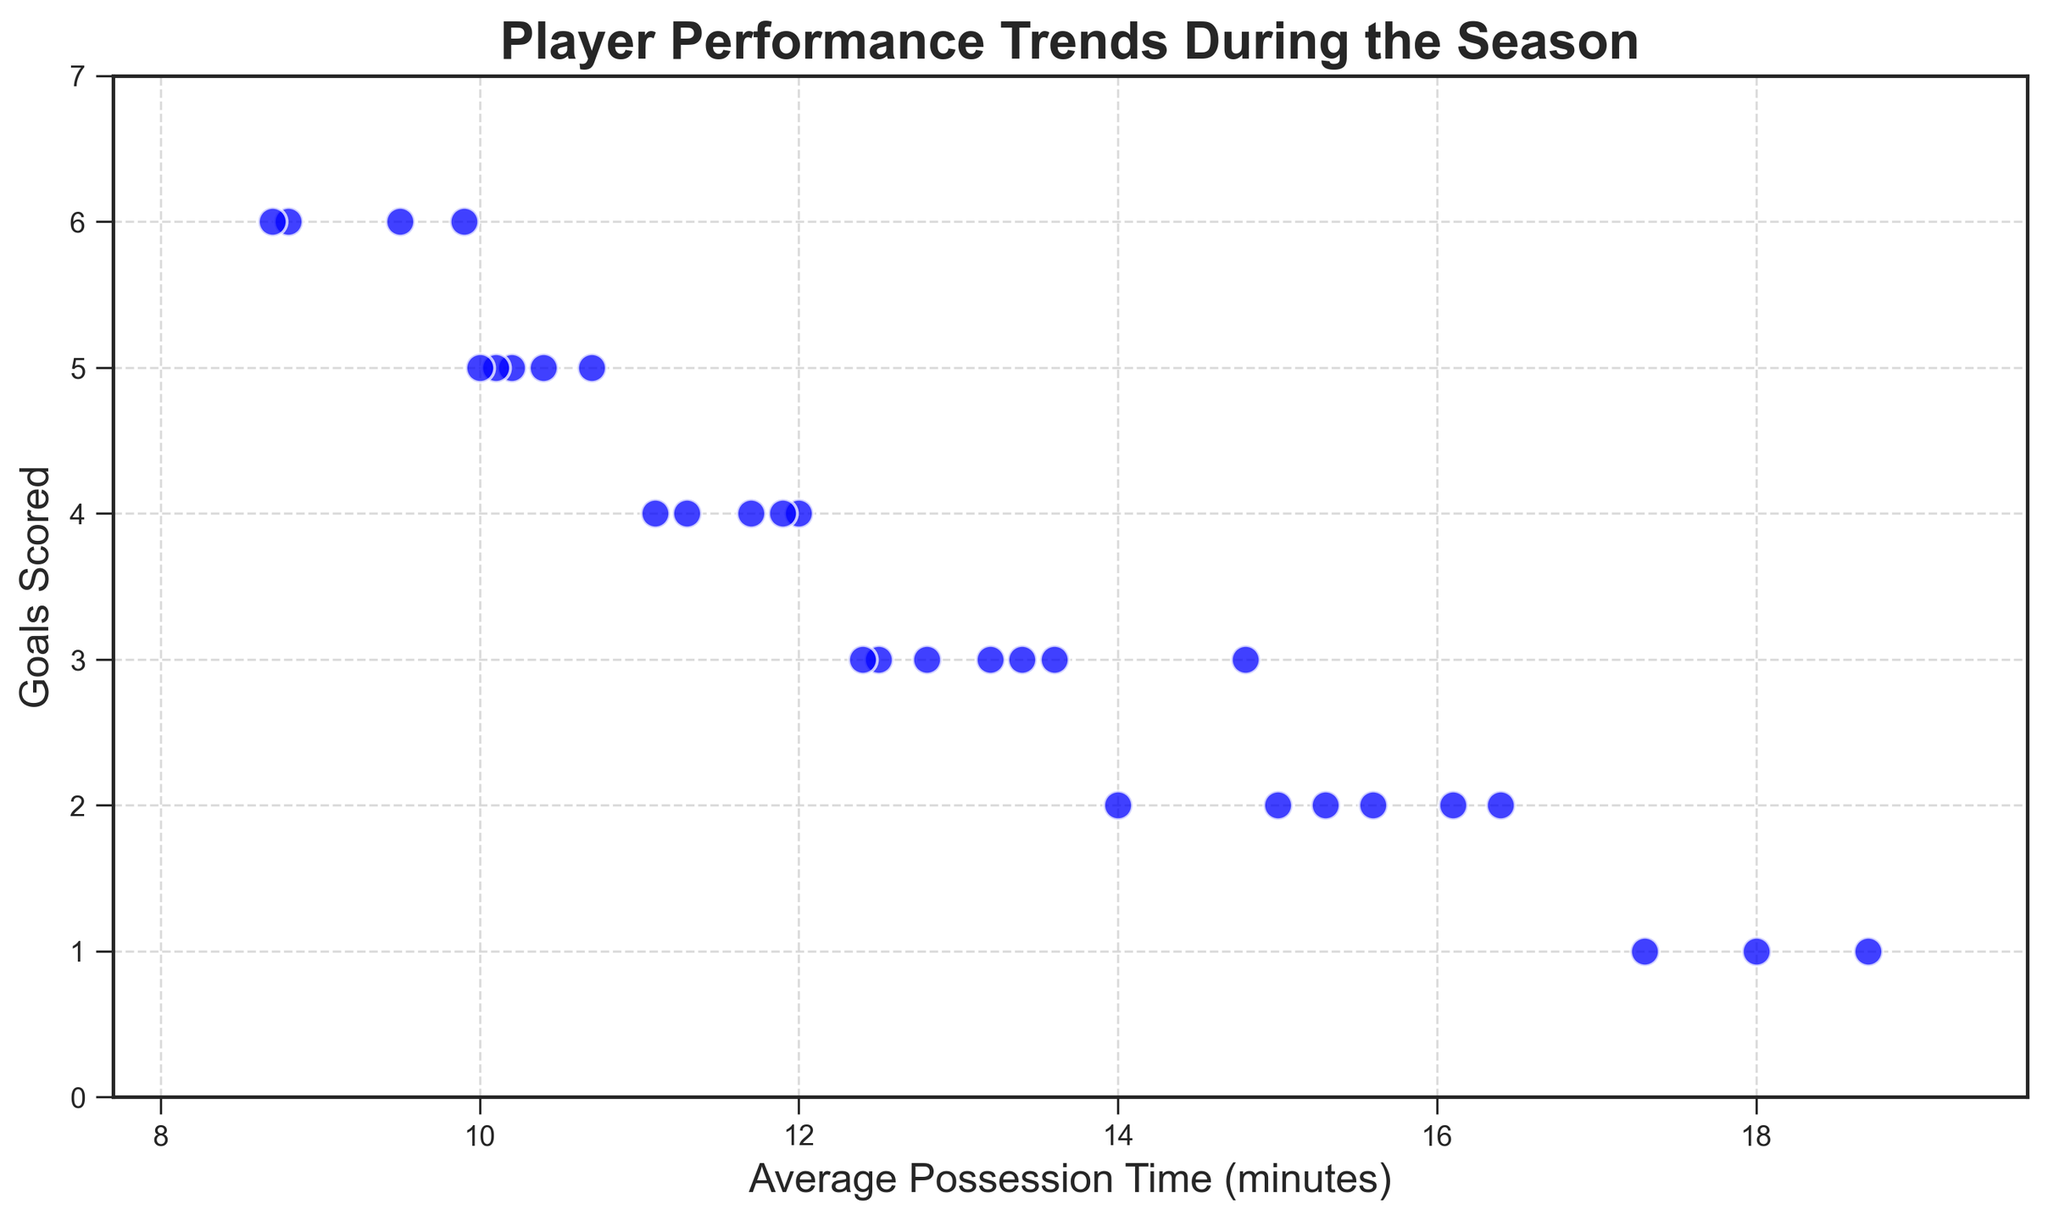Which match shows the highest number of goals scored? Look for the data point on the scatter plot that has the highest y-axis value (Goals Scored). The highest value for Goals Scored is 6. Locate this point along the x-axis to find the match.
Answer: Match 7, 12, 23, or 29 What is the median of the goals scored across the season? List all the goals scored values: [3, 2, 5, 1, 4, 3, 6, 2, 3, 4, 5, 6, 1, 2, 3, 4, 5, 2, 3, 4, 1, 5, 6, 2, 3, 4, 2, 5, 6, 3]. To find the median, sort these values and take the middle value(s). In this case, the sorted list is [1, 1, 1, 2, 2, 2, 2, 2, 3, 3, 3, 3, 3, 4, 4, 4, 4, 4, 5, 5, 5, 5, 6, 6, 6, 6]. The median is between the 15th and 16th values: (4+4)/2 = 4.
Answer: 4 Is there a correlation between average possession time and goals scored? Observe the trend of the scatter plot points. If the points form a clear upward or downward trend, it indicates correlation. Here, higher possession time doesn't consistently correspond to more goals, suggesting no strong linear correlation.
Answer: No Comparing matches 7 and 11, which had more average possession time? Find matches 7 and 11 on the scatter plot by looking up their goals scored (both 6 for match 7 and 5 for match 11) then check their average possession times on the x-axis. Match 7 corresponds to ~9.9 minutes, match 11 to ~10.4 minutes.
Answer: Match 11 What is the range of average possession times across the season? Look at the x-axis values from the smallest to the largest value. The minimum average possession time is 8.7 minutes (match 29) and the maximum is 18.7 minutes (match 4). Calculate the range: 18.7 - 8.7 = 10
Answer: 10 minutes How does the goals scored in match 4 compare to match 22 in terms of possession time? Locate match 4 (1 goal scored, 18.7 min possession) and match 22 (5 goals scored, 10.1 min possession). Compare the average possession times: 18.7 minutes vs. 10.1 minutes. Match 4 has a higher possession time.
Answer: Match 4 had higher possession time What is the average number of goals scored for matches with possession time greater than 15 minutes? Identify matches with possession time > 15 minutes: [2, 4, 8, 13, 18, 21, 24, 27]. Extract goals scored for these matches: [2, 1, 2, 1, 2, 1, 2, 2]. Calculate the average: (2+1+2+1+2+1+2+2)/8 = 13/8 = 1.625.
Answer: 1.625 Which match had the lowest goals scored with an average possession time of less than 10 minutes? Filter the matches where average possession time is less than 10 minutes: [7, 12, 23, 29] and compare their Goals Scored values. Match 7: 6 goals, Match 12: 6 goals, Match 23: 6 goals, Match 29: 6 goals. None had fewer than 6 goals.
Answer: None What is the relationship between possession time and goals scored ratio when possession time is within 10 to 15 minutes? Filter the matches with possession time between 10 and 15 minutes: [1, 3, 5, 6, 9, 10, 11, 14, 15, 16, 17, 19, 20, 25, 26, 30]. Average out their respective Goals Scored values from the data, then analyze the trend. Given these values fluctuate rather than showing a clear pattern, the ratio shows variability without strong consistency.
Answer: Varied Among all matches with 6 goals scored, which match had the shortest possession time? Identify matches with 6 goals: [7, 12, 23, 29]. Compare their possession times: 9.9, 8.8, 9.5, 8.7. Match 29 has the shortest possession time: 8.7 minutes.
Answer: Match 29 